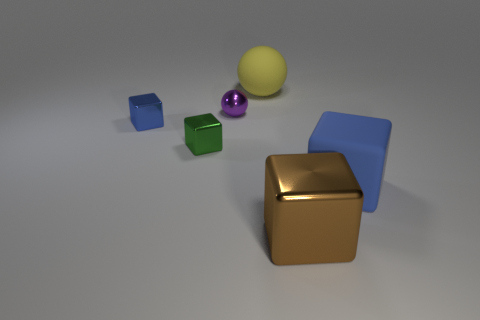Is the material of the tiny green object the same as the blue cube right of the yellow rubber object?
Offer a terse response. No. There is a shiny block that is right of the purple object; is there a matte thing to the right of it?
Give a very brief answer. Yes. What is the material of the other big blue object that is the same shape as the blue shiny thing?
Provide a short and direct response. Rubber. How many things are in front of the blue block that is in front of the small blue block?
Your answer should be compact. 1. Is there anything else of the same color as the large metal thing?
Your response must be concise. No. How many things are yellow metallic spheres or metal things that are on the right side of the purple sphere?
Your answer should be compact. 1. What is the material of the small green block that is to the left of the large matte thing behind the ball that is in front of the large ball?
Give a very brief answer. Metal. The object that is the same material as the big yellow sphere is what size?
Your response must be concise. Large. There is a large cube in front of the large matte object right of the yellow matte object; what is its color?
Your response must be concise. Brown. What number of purple things have the same material as the large brown cube?
Ensure brevity in your answer.  1. 